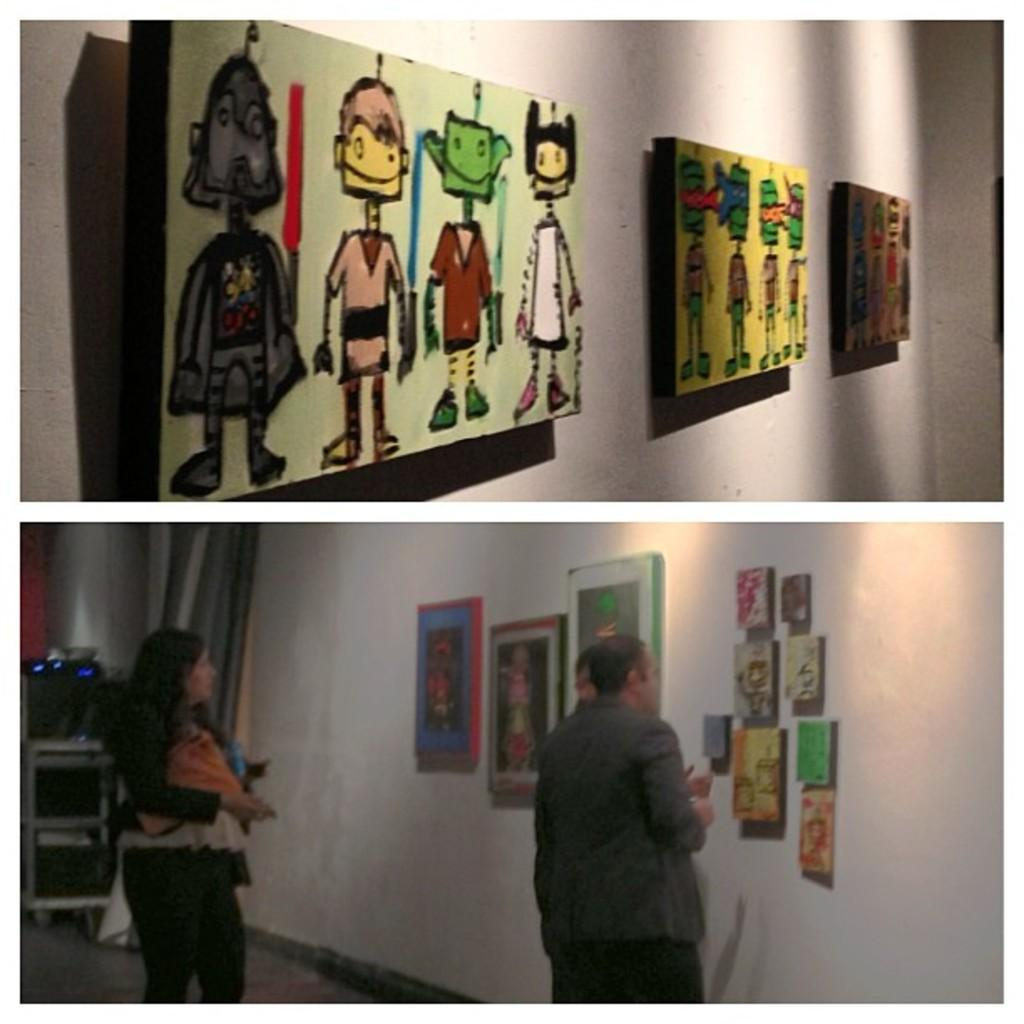What type of artwork is the image? The image is a collage. What subjects are depicted in the collage? There are pictures of walls, paintings, and pictures of persons in the collage. What color is the plant in the image? There is no plant present in the image; it is a collage featuring pictures of walls, paintings, and pictures of persons. 